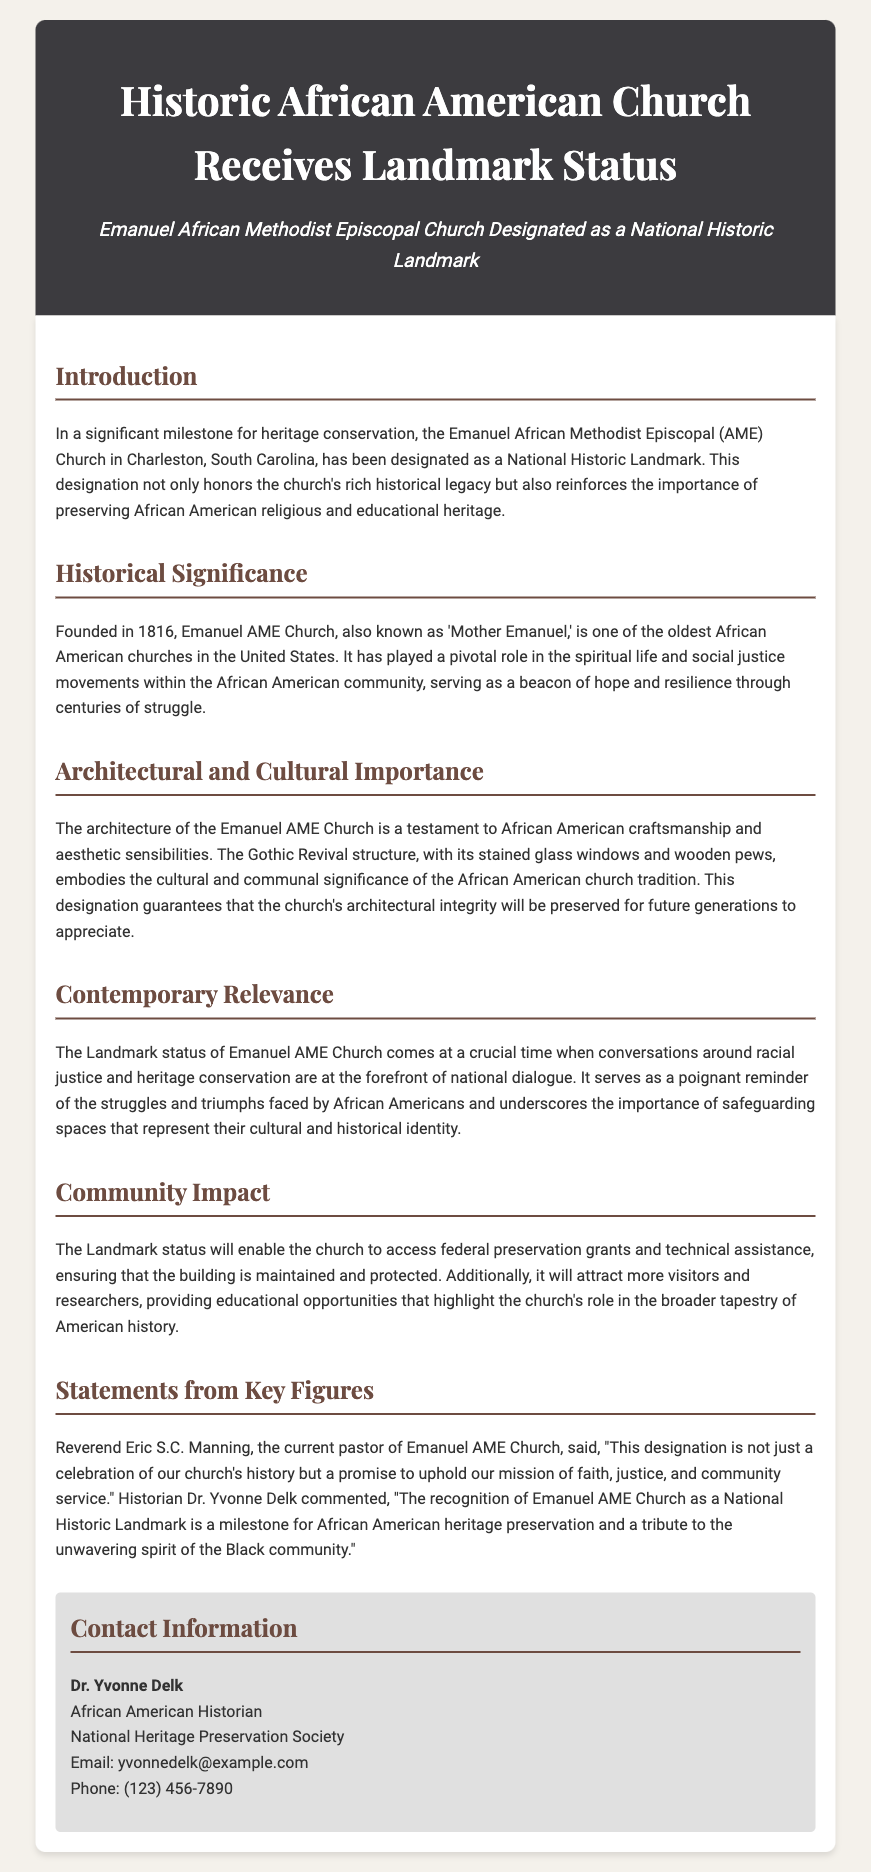What is the name of the church designated as a National Historic Landmark? The church designated as a National Historic Landmark is mentioned as Emanuel African Methodist Episcopal Church.
Answer: Emanuel African Methodist Episcopal Church In what year was Emanuel AME Church founded? The founding year of Emanuel AME Church is specified in the document.
Answer: 1816 What architectural style is the Emanuel AME Church? The architectural style of Emanuel AME Church is described in the document as Gothic Revival.
Answer: Gothic Revival Who is the current pastor of Emanuel AME Church? The document provides the name of the current pastor of the church.
Answer: Reverend Eric S.C. Manning What impact does the Landmark status have on the church? The document explains that the Landmark status allows access to federal preservation grants and technical assistance.
Answer: Access to federal preservation grants How does the church's designation relate to contemporary issues? The document notes that the designation serves as a reminder of struggles and triumphs faced by African Americans, linking it to contemporary issues of racial justice.
Answer: Racial justice What is emphasized as a vital aspect of preserving Emanuel AME Church? The document emphasizes the importance of safeguarding spaces that represent African Americans' cultural and historical identity.
Answer: Safeguarding spaces What is the contact information for Dr. Yvonne Delk? The document provides contact details for Dr. Yvonne Delk under the contact information section.
Answer: Email: yvonnedelk@example.com, Phone: (123) 456-7890 